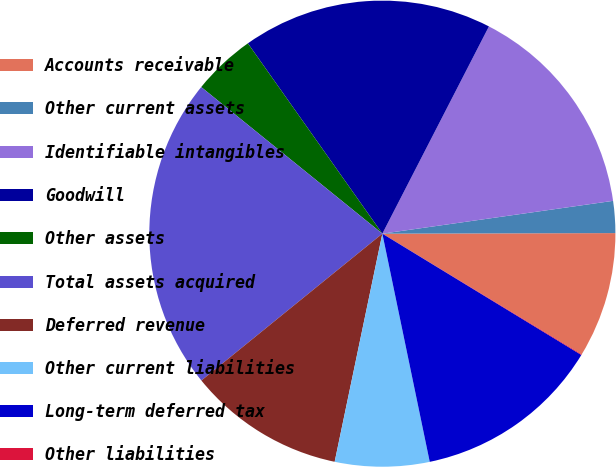Convert chart. <chart><loc_0><loc_0><loc_500><loc_500><pie_chart><fcel>Accounts receivable<fcel>Other current assets<fcel>Identifiable intangibles<fcel>Goodwill<fcel>Other assets<fcel>Total assets acquired<fcel>Deferred revenue<fcel>Other current liabilities<fcel>Long-term deferred tax<fcel>Other liabilities<nl><fcel>8.7%<fcel>2.21%<fcel>15.19%<fcel>17.35%<fcel>4.38%<fcel>21.68%<fcel>10.87%<fcel>6.54%<fcel>13.03%<fcel>0.05%<nl></chart> 